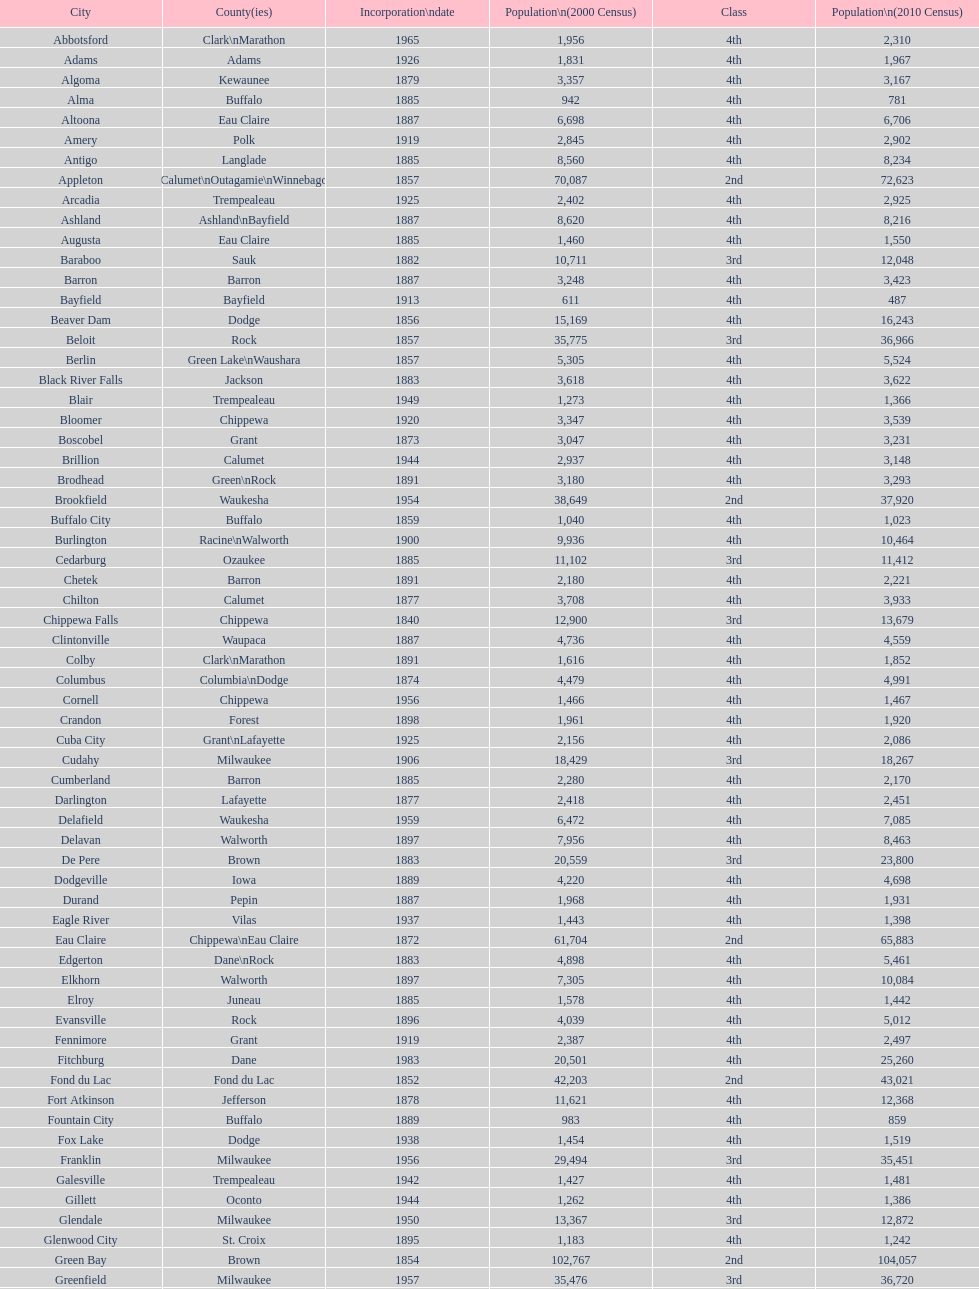Which city in wisconsin is the most populous, based on the 2010 census? Milwaukee. Write the full table. {'header': ['City', 'County(ies)', 'Incorporation\\ndate', 'Population\\n(2000 Census)', 'Class', 'Population\\n(2010 Census)'], 'rows': [['Abbotsford', 'Clark\\nMarathon', '1965', '1,956', '4th', '2,310'], ['Adams', 'Adams', '1926', '1,831', '4th', '1,967'], ['Algoma', 'Kewaunee', '1879', '3,357', '4th', '3,167'], ['Alma', 'Buffalo', '1885', '942', '4th', '781'], ['Altoona', 'Eau Claire', '1887', '6,698', '4th', '6,706'], ['Amery', 'Polk', '1919', '2,845', '4th', '2,902'], ['Antigo', 'Langlade', '1885', '8,560', '4th', '8,234'], ['Appleton', 'Calumet\\nOutagamie\\nWinnebago', '1857', '70,087', '2nd', '72,623'], ['Arcadia', 'Trempealeau', '1925', '2,402', '4th', '2,925'], ['Ashland', 'Ashland\\nBayfield', '1887', '8,620', '4th', '8,216'], ['Augusta', 'Eau Claire', '1885', '1,460', '4th', '1,550'], ['Baraboo', 'Sauk', '1882', '10,711', '3rd', '12,048'], ['Barron', 'Barron', '1887', '3,248', '4th', '3,423'], ['Bayfield', 'Bayfield', '1913', '611', '4th', '487'], ['Beaver Dam', 'Dodge', '1856', '15,169', '4th', '16,243'], ['Beloit', 'Rock', '1857', '35,775', '3rd', '36,966'], ['Berlin', 'Green Lake\\nWaushara', '1857', '5,305', '4th', '5,524'], ['Black River Falls', 'Jackson', '1883', '3,618', '4th', '3,622'], ['Blair', 'Trempealeau', '1949', '1,273', '4th', '1,366'], ['Bloomer', 'Chippewa', '1920', '3,347', '4th', '3,539'], ['Boscobel', 'Grant', '1873', '3,047', '4th', '3,231'], ['Brillion', 'Calumet', '1944', '2,937', '4th', '3,148'], ['Brodhead', 'Green\\nRock', '1891', '3,180', '4th', '3,293'], ['Brookfield', 'Waukesha', '1954', '38,649', '2nd', '37,920'], ['Buffalo City', 'Buffalo', '1859', '1,040', '4th', '1,023'], ['Burlington', 'Racine\\nWalworth', '1900', '9,936', '4th', '10,464'], ['Cedarburg', 'Ozaukee', '1885', '11,102', '3rd', '11,412'], ['Chetek', 'Barron', '1891', '2,180', '4th', '2,221'], ['Chilton', 'Calumet', '1877', '3,708', '4th', '3,933'], ['Chippewa Falls', 'Chippewa', '1840', '12,900', '3rd', '13,679'], ['Clintonville', 'Waupaca', '1887', '4,736', '4th', '4,559'], ['Colby', 'Clark\\nMarathon', '1891', '1,616', '4th', '1,852'], ['Columbus', 'Columbia\\nDodge', '1874', '4,479', '4th', '4,991'], ['Cornell', 'Chippewa', '1956', '1,466', '4th', '1,467'], ['Crandon', 'Forest', '1898', '1,961', '4th', '1,920'], ['Cuba City', 'Grant\\nLafayette', '1925', '2,156', '4th', '2,086'], ['Cudahy', 'Milwaukee', '1906', '18,429', '3rd', '18,267'], ['Cumberland', 'Barron', '1885', '2,280', '4th', '2,170'], ['Darlington', 'Lafayette', '1877', '2,418', '4th', '2,451'], ['Delafield', 'Waukesha', '1959', '6,472', '4th', '7,085'], ['Delavan', 'Walworth', '1897', '7,956', '4th', '8,463'], ['De Pere', 'Brown', '1883', '20,559', '3rd', '23,800'], ['Dodgeville', 'Iowa', '1889', '4,220', '4th', '4,698'], ['Durand', 'Pepin', '1887', '1,968', '4th', '1,931'], ['Eagle River', 'Vilas', '1937', '1,443', '4th', '1,398'], ['Eau Claire', 'Chippewa\\nEau Claire', '1872', '61,704', '2nd', '65,883'], ['Edgerton', 'Dane\\nRock', '1883', '4,898', '4th', '5,461'], ['Elkhorn', 'Walworth', '1897', '7,305', '4th', '10,084'], ['Elroy', 'Juneau', '1885', '1,578', '4th', '1,442'], ['Evansville', 'Rock', '1896', '4,039', '4th', '5,012'], ['Fennimore', 'Grant', '1919', '2,387', '4th', '2,497'], ['Fitchburg', 'Dane', '1983', '20,501', '4th', '25,260'], ['Fond du Lac', 'Fond du Lac', '1852', '42,203', '2nd', '43,021'], ['Fort Atkinson', 'Jefferson', '1878', '11,621', '4th', '12,368'], ['Fountain City', 'Buffalo', '1889', '983', '4th', '859'], ['Fox Lake', 'Dodge', '1938', '1,454', '4th', '1,519'], ['Franklin', 'Milwaukee', '1956', '29,494', '3rd', '35,451'], ['Galesville', 'Trempealeau', '1942', '1,427', '4th', '1,481'], ['Gillett', 'Oconto', '1944', '1,262', '4th', '1,386'], ['Glendale', 'Milwaukee', '1950', '13,367', '3rd', '12,872'], ['Glenwood City', 'St. Croix', '1895', '1,183', '4th', '1,242'], ['Green Bay', 'Brown', '1854', '102,767', '2nd', '104,057'], ['Greenfield', 'Milwaukee', '1957', '35,476', '3rd', '36,720'], ['Green Lake', 'Green Lake', '1962', '1,100', '4th', '960'], ['Greenwood', 'Clark', '1891', '1,079', '4th', '1,026'], ['Hartford', 'Dodge\\nWashington', '1883', '10,905', '3rd', '14,223'], ['Hayward', 'Sawyer', '1915', '2,129', '4th', '2,318'], ['Hillsboro', 'Vernon', '1885', '1,302', '4th', '1,417'], ['Horicon', 'Dodge', '1897', '3,775', '4th', '3,655'], ['Hudson', 'St. Croix', '1858', '8,775', '4th', '12,719'], ['Hurley', 'Iron', '1918', '1,818', '4th', '1,547'], ['Independence', 'Trempealeau', '1942', '1,244', '4th', '1,336'], ['Janesville', 'Rock', '1853', '59,498', '2nd', '63,575'], ['Jefferson', 'Jefferson', '1878', '7,338', '4th', '7,973'], ['Juneau', 'Dodge', '1887', '2,485', '4th', '2,814'], ['Kaukauna', 'Outagamie', '1885', '12,983', '3rd', '15,462'], ['Kenosha', 'Kenosha', '1850', '90,352', '2nd', '99,218'], ['Kewaunee', 'Kewaunee', '1883', '2,806', '4th', '2,952'], ['Kiel', 'Calumet\\nManitowoc', '1920', '3,450', '4th', '3,738'], ['La Crosse', 'La Crosse', '1856', '51,818', '2nd', '51,320'], ['Ladysmith', 'Rusk', '1905', '3,932', '4th', '3,414'], ['Lake Geneva', 'Walworth', '1883', '7,148', '4th', '7,651'], ['Lake Mills', 'Jefferson', '1905', '4,843', '4th', '5,708'], ['Lancaster', 'Grant', '1878', '4,070', '4th', '3,868'], ['Lodi', 'Columbia', '1941', '2,882', '4th', '3,050'], ['Loyal', 'Clark', '1948', '1,308', '4th', '1,261'], ['Madison', 'Dane', '1856', '208,054', '2nd', '233,209'], ['Manawa', 'Waupaca', '1954', '1,330', '4th', '1,371'], ['Manitowoc', 'Manitowoc', '1870', '34,053', '3rd', '33,736'], ['Marinette', 'Marinette', '1887', '11,749', '3rd', '10,968'], ['Marion', 'Shawano\\nWaupaca', '1898', '1,297', '4th', '1,260'], ['Markesan', 'Green Lake', '1959', '1,396', '4th', '1,476'], ['Marshfield', 'Marathon\\nWood', '1883', '18,800', '3rd', '19,118'], ['Mauston', 'Juneau', '1883', '3,740', '4th', '4,423'], ['Mayville', 'Dodge', '1885', '4,902', '4th', '5,154'], ['Medford', 'Taylor', '1889', '4,350', '4th', '4,326'], ['Mellen', 'Ashland', '1907', '845', '4th', '731'], ['Menasha', 'Calumet\\nWinnebago', '1874', '16,331', '3rd', '17,353'], ['Menomonie', 'Dunn', '1882', '14,937', '4th', '16,264'], ['Mequon', 'Ozaukee', '1957', '22,643', '4th', '23,132'], ['Merrill', 'Lincoln', '1883', '10,146', '4th', '9,661'], ['Middleton', 'Dane', '1963', '15,770', '3rd', '17,442'], ['Milton', 'Rock', '1969', '5,132', '4th', '5,546'], ['Milwaukee', 'Milwaukee\\nWashington\\nWaukesha', '1846', '596,974', '1st', '594,833'], ['Mineral Point', 'Iowa', '1857', '2,617', '4th', '2,487'], ['Mondovi', 'Buffalo', '1889', '2,634', '4th', '2,777'], ['Monona', 'Dane', '1969', '8,018', '4th', '7,533'], ['Monroe', 'Green', '1882', '10,843', '4th', '10,827'], ['Montello', 'Marquette', '1938', '1,397', '4th', '1,495'], ['Montreal', 'Iron', '1924', '838', '4th', '807'], ['Mosinee', 'Marathon', '1931', '4,063', '4th', '3,988'], ['Muskego', 'Waukesha', '1964', '21,397', '3rd', '24,135'], ['Neenah', 'Winnebago', '1873', '24,507', '3rd', '25,501'], ['Neillsville', 'Clark', '1882', '2,731', '4th', '2,463'], ['Nekoosa', 'Wood', '1926', '2,590', '4th', '2,580'], ['New Berlin', 'Waukesha', '1959', '38,220', '3rd', '39,584'], ['New Holstein', 'Calumet', '1889', '3,301', '4th', '3,236'], ['New Lisbon', 'Juneau', '1889', '1,436', '4th', '2,554'], ['New London', 'Outagamie\\nWaupaca', '1877', '7,085', '4th', '7,295'], ['New Richmond', 'St. Croix', '1885', '6,310', '4th', '8,375'], ['Niagara', 'Marinette', '1992', '1,880', '4th', '1,624'], ['Oak Creek', 'Milwaukee', '1955', '28,456', '3rd', '34,451'], ['Oconomowoc', 'Waukesha', '1875', '12,382', '3rd', '15,712'], ['Oconto', 'Oconto', '1869', '4,708', '4th', '4,513'], ['Oconto Falls', 'Oconto', '1919', '2,843', '4th', '2,891'], ['Omro', 'Winnebago', '1944', '3,177', '4th', '3,517'], ['Onalaska', 'La Crosse', '1887', '14,839', '4th', '17,736'], ['Oshkosh', 'Winnebago', '1853', '62,916', '2nd', '66,083'], ['Osseo', 'Trempealeau', '1941', '1,669', '4th', '1,701'], ['Owen', 'Clark', '1925', '936', '4th', '940'], ['Park Falls', 'Price', '1912', '2,739', '4th', '2,462'], ['Peshtigo', 'Marinette', '1903', '3,474', '4th', '3,502'], ['Pewaukee', 'Waukesha', '1999', '11,783', '3rd', '13,195'], ['Phillips', 'Price', '1891', '1,675', '4th', '1,478'], ['Pittsville', 'Wood', '1887', '866', '4th', '874'], ['Platteville', 'Grant', '1876', '9,989', '4th', '11,224'], ['Plymouth', 'Sheboygan', '1877', '7,781', '4th', '8,445'], ['Port Washington', 'Ozaukee', '1882', '10,467', '4th', '11,250'], ['Portage', 'Columbia', '1854', '9,728', '4th', '10,324'], ['Prairie du Chien', 'Crawford', '1872', '6,018', '4th', '5,911'], ['Prescott', 'Pierce', '1857', '3,764', '4th', '4,258'], ['Princeton', 'Green Lake', '1920', '1,504', '4th', '1,214'], ['Racine', 'Racine', '1848', '81,855', '2nd', '78,860'], ['Reedsburg', 'Sauk', '1887', '7,827', '4th', '10,014'], ['Rhinelander', 'Oneida', '1894', '7,735', '4th', '7,798'], ['Rice Lake', 'Barron', '1887', '8,312', '4th', '8,438'], ['Richland Center', 'Richland', '1887', '5,114', '4th', '5,184'], ['Ripon', 'Fond du Lac', '1858', '7,450', '4th', '7,733'], ['River Falls', 'Pierce\\nSt. Croix', '1875', '12,560', '3rd', '15,000'], ['St. Croix Falls', 'Polk', '1958', '2,033', '4th', '2,133'], ['St. Francis', 'Milwaukee', '1951', '8,662', '4th', '9,365'], ['Schofield', 'Marathon', '1951', '2,117', '4th', '2,169'], ['Seymour', 'Outagamie', '1879', '3,335', '4th', '3,451'], ['Shawano', 'Shawano', '1874', '8,298', '4th', '9,305'], ['Sheboygan', 'Sheboygan', '1853', '50,792', '2nd', '49,288'], ['Sheboygan Falls', 'Sheboygan', '1913', '6,772', '4th', '7,775'], ['Shell Lake', 'Washburn', '1961', '1,309', '4th', '1,347'], ['Shullsburg', 'Lafayette', '1889', '1,246', '4th', '1,226'], ['South Milwaukee', 'Milwaukee', '1897', '21,256', '4th', '21,156'], ['Sparta', 'Monroe', '1883', '8,648', '4th', '9,522'], ['Spooner', 'Washburn', '1909', '2,653', '4th', '2,682'], ['Stanley', 'Chippewa\\nClark', '1898', '1,898', '4th', '3,608'], ['Stevens Point', 'Portage', '1858', '24,551', '3rd', '26,717'], ['Stoughton', 'Dane', '1882', '12,354', '4th', '12,611'], ['Sturgeon Bay', 'Door', '1883', '9,437', '4th', '9,144'], ['Sun Prairie', 'Dane', '1958', '20,369', '3rd', '29,364'], ['Superior', 'Douglas', '1858', '27,368', '2nd', '27,244'], ['Thorp', 'Clark', '1948', '1,536', '4th', '1,621'], ['Tomah', 'Monroe', '1883', '8,419', '4th', '9,093'], ['Tomahawk', 'Lincoln', '1891', '3,770', '4th', '3,397'], ['Two Rivers', 'Manitowoc', '1878', '12,639', '3rd', '11,712'], ['Verona', 'Dane', '1977', '7,052', '4th', '10,619'], ['Viroqua', 'Vernon', '1885', '4,335', '4th', '5,079'], ['Washburn', 'Bayfield', '1904', '2,280', '4th', '2,117'], ['Waterloo', 'Jefferson', '1962', '3,259', '4th', '3,333'], ['Watertown', 'Dodge\\nJefferson', '1853', '21,598', '3rd', '23,861'], ['Waukesha', 'Waukesha', '1895', '64,825', '2nd', '70,718'], ['Waupaca', 'Waupaca', '1878', '5,676', '4th', '6,069'], ['Waupun', 'Dodge\\nFond du Lac', '1878', '10,944', '4th', '11,340'], ['Wausau', 'Marathon', '1872', '38,426', '3rd', '39,106'], ['Wautoma', 'Waushara', '1901', '1,998', '4th', '2,218'], ['Wauwatosa', 'Milwaukee', '1897', '47,271', '2nd', '46,396'], ['West Allis', 'Milwaukee', '1906', '61,254', '2nd', '60,411'], ['West Bend', 'Washington', '1885', '28,152', '3rd', '31,078'], ['Westby', 'Vernon', '1920', '2,045', '4th', '2,200'], ['Weyauwega', 'Waupaca', '1939', '1,806', '4th', '1,900'], ['Whitehall', 'Trempealeau', '1941', '1,651', '4th', '1,558'], ['Whitewater', 'Jefferson\\nWalworth', '1885', '13,437', '4th', '14,390'], ['Wisconsin Dells', 'Adams\\nColumbia\\nJuneau\\nSauk', '1925', '2,418', '4th', '2,678'], ['Wisconsin Rapids', 'Wood', '1869', '18,435', '3rd', '18,367']]} 